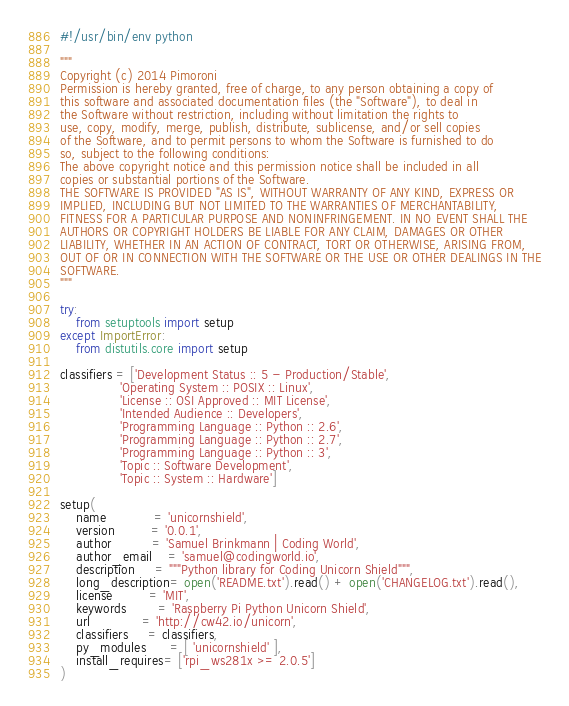<code> <loc_0><loc_0><loc_500><loc_500><_Python_>#!/usr/bin/env python

"""
Copyright (c) 2014 Pimoroni
Permission is hereby granted, free of charge, to any person obtaining a copy of
this software and associated documentation files (the "Software"), to deal in
the Software without restriction, including without limitation the rights to
use, copy, modify, merge, publish, distribute, sublicense, and/or sell copies
of the Software, and to permit persons to whom the Software is furnished to do
so, subject to the following conditions:
The above copyright notice and this permission notice shall be included in all
copies or substantial portions of the Software.
THE SOFTWARE IS PROVIDED "AS IS", WITHOUT WARRANTY OF ANY KIND, EXPRESS OR
IMPLIED, INCLUDING BUT NOT LIMITED TO THE WARRANTIES OF MERCHANTABILITY,
FITNESS FOR A PARTICULAR PURPOSE AND NONINFRINGEMENT. IN NO EVENT SHALL THE
AUTHORS OR COPYRIGHT HOLDERS BE LIABLE FOR ANY CLAIM, DAMAGES OR OTHER
LIABILITY, WHETHER IN AN ACTION OF CONTRACT, TORT OR OTHERWISE, ARISING FROM,
OUT OF OR IN CONNECTION WITH THE SOFTWARE OR THE USE OR OTHER DEALINGS IN THE
SOFTWARE.
"""

try:
    from setuptools import setup
except ImportError:
    from distutils.core import setup

classifiers = ['Development Status :: 5 - Production/Stable',
               'Operating System :: POSIX :: Linux',
               'License :: OSI Approved :: MIT License',
               'Intended Audience :: Developers',
               'Programming Language :: Python :: 2.6',
               'Programming Language :: Python :: 2.7',
               'Programming Language :: Python :: 3',
               'Topic :: Software Development',
               'Topic :: System :: Hardware']

setup(
    name            = 'unicornshield',
    version         = '0.0.1',
    author          = 'Samuel Brinkmann | Coding World',
    author_email    = 'samuel@codingworld.io',
    description     = """Python library for Coding Unicorn Shield""",
    long_description= open('README.txt').read() + open('CHANGELOG.txt').read(),
    license         = 'MIT',
    keywords        = 'Raspberry Pi Python Unicorn Shield',
    url             = 'http://cw42.io/unicorn',
    classifiers     = classifiers,
    py_modules      = [ 'unicornshield' ],
    install_requires= ['rpi_ws281x >= 2.0.5']
)
</code> 